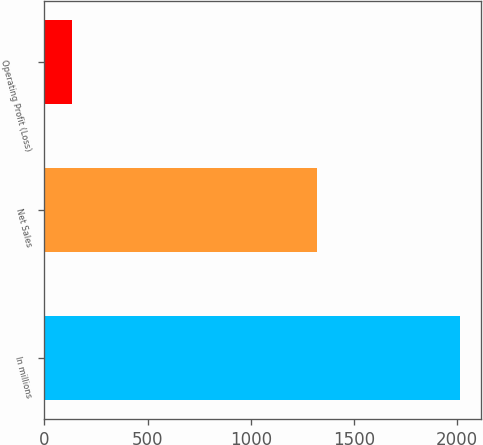Convert chart to OTSL. <chart><loc_0><loc_0><loc_500><loc_500><bar_chart><fcel>In millions<fcel>Net Sales<fcel>Operating Profit (Loss)<nl><fcel>2014<fcel>1321<fcel>136<nl></chart> 